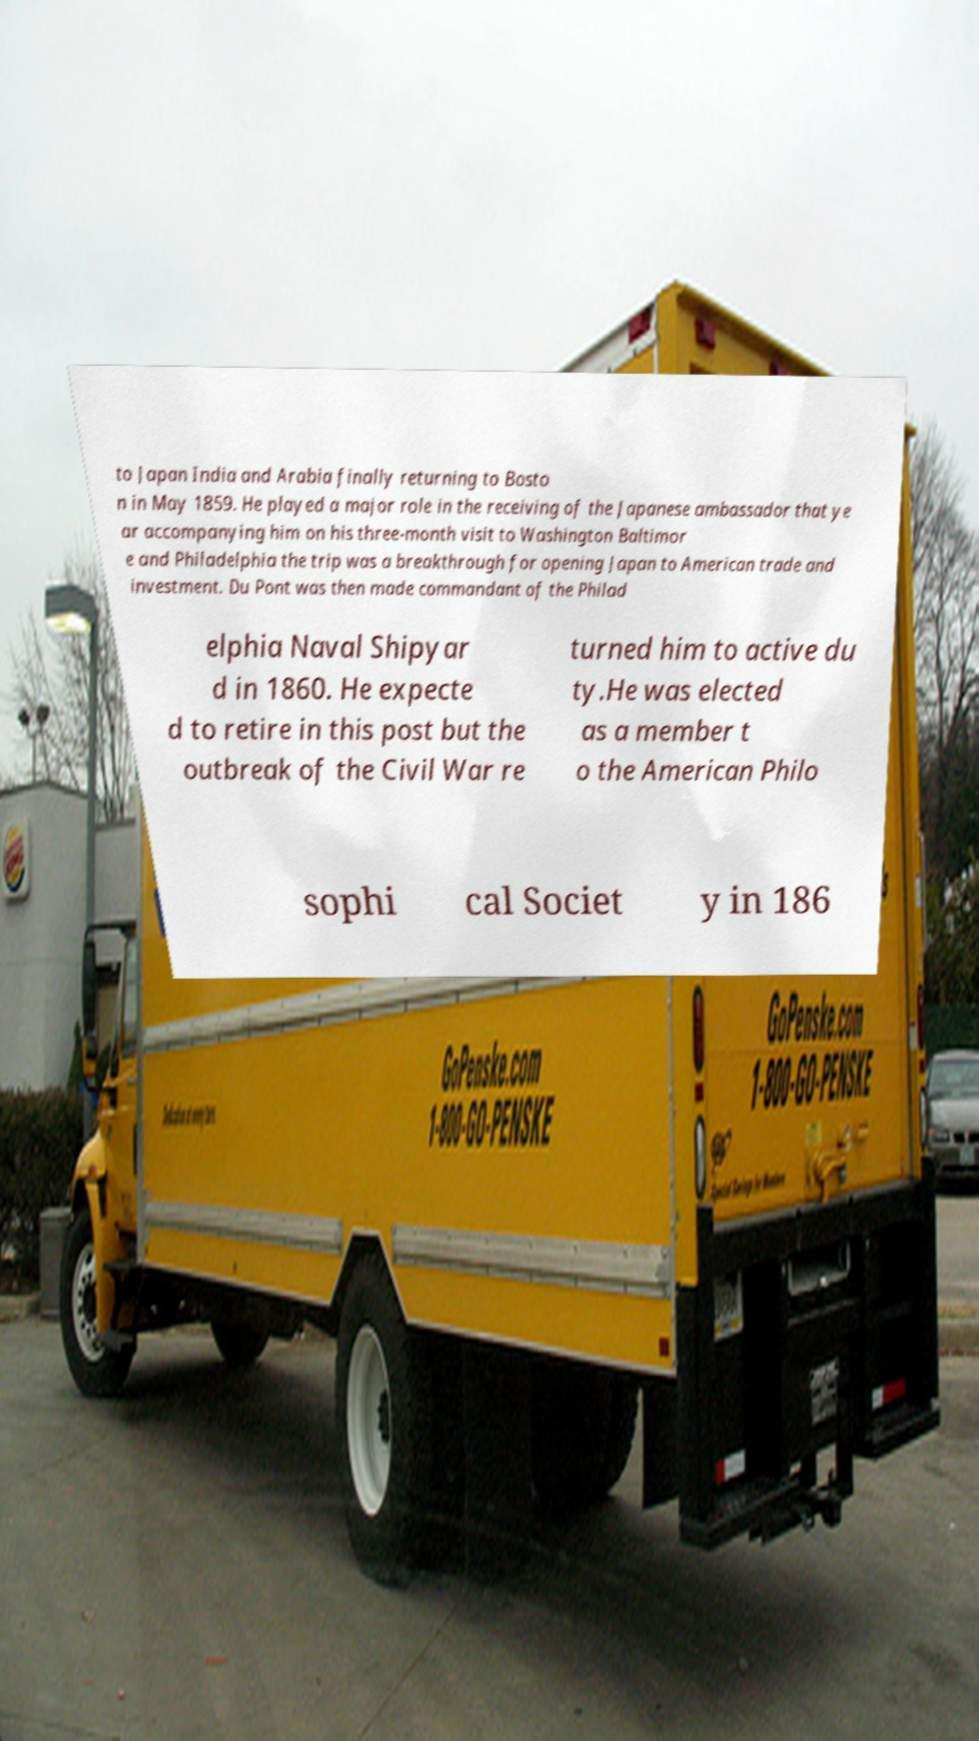There's text embedded in this image that I need extracted. Can you transcribe it verbatim? to Japan India and Arabia finally returning to Bosto n in May 1859. He played a major role in the receiving of the Japanese ambassador that ye ar accompanying him on his three-month visit to Washington Baltimor e and Philadelphia the trip was a breakthrough for opening Japan to American trade and investment. Du Pont was then made commandant of the Philad elphia Naval Shipyar d in 1860. He expecte d to retire in this post but the outbreak of the Civil War re turned him to active du ty.He was elected as a member t o the American Philo sophi cal Societ y in 186 